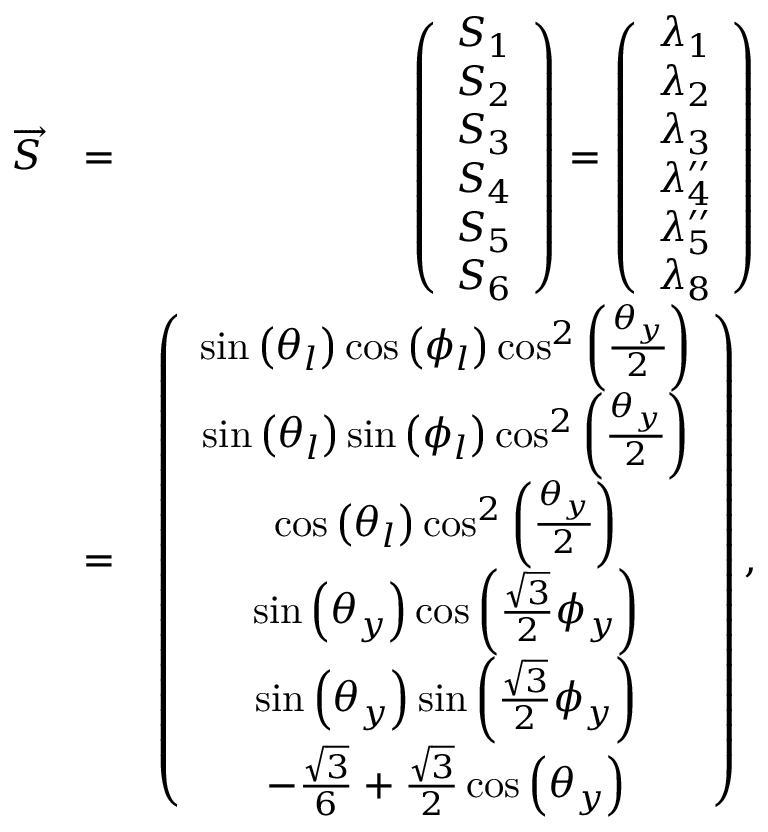Convert formula to latex. <formula><loc_0><loc_0><loc_500><loc_500>\begin{array} { r l r } { \overrightarrow { S } } & { = } & { \left ( \begin{array} { c } { S _ { 1 } } \\ { S _ { 2 } } \\ { S _ { 3 } } \\ { S _ { 4 } } \\ { S _ { 5 } } \\ { S _ { 6 } } \end{array} \right ) = \left ( \begin{array} { c } { \lambda _ { 1 } } \\ { \lambda _ { 2 } } \\ { \lambda _ { 3 } } \\ { \lambda _ { 4 } ^ { \prime \prime } } \\ { \lambda _ { 5 } ^ { \prime \prime } } \\ { \lambda _ { 8 } } \end{array} \right ) } \\ & { = } & { \left ( \begin{array} { c } { \sin \left ( \theta _ { l } \right ) \cos \left ( \phi _ { l } \right ) \cos ^ { 2 } \left ( \frac { \theta _ { y } } { 2 } \right ) } \\ { \sin \left ( \theta _ { l } \right ) \sin \left ( \phi _ { l } \right ) \cos ^ { 2 } \left ( \frac { \theta _ { y } } { 2 } \right ) } \\ { \cos \left ( \theta _ { l } \right ) \cos ^ { 2 } \left ( \frac { \theta _ { y } } { 2 } \right ) } \\ { \sin \left ( \theta _ { y } \right ) \cos \left ( \frac { \sqrt { 3 } } { 2 } \phi _ { y } \right ) } \\ { \sin \left ( \theta _ { y } \right ) \sin \left ( \frac { \sqrt { 3 } } { 2 } \phi _ { y } \right ) } \\ { - \frac { \sqrt { 3 } } { 6 } + \frac { \sqrt { 3 } } { 2 } \cos \left ( \theta _ { y } \right ) } \end{array} \right ) , } \end{array}</formula> 